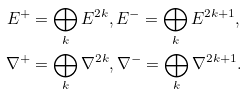Convert formula to latex. <formula><loc_0><loc_0><loc_500><loc_500>E ^ { + } & = \bigoplus _ { k } E ^ { 2 k } , E ^ { - } = \bigoplus _ { k } E ^ { 2 k + 1 } , \\ \nabla ^ { + } & = \bigoplus _ { k } \nabla ^ { 2 k } , \nabla ^ { - } = \bigoplus _ { k } \nabla ^ { 2 k + 1 } .</formula> 